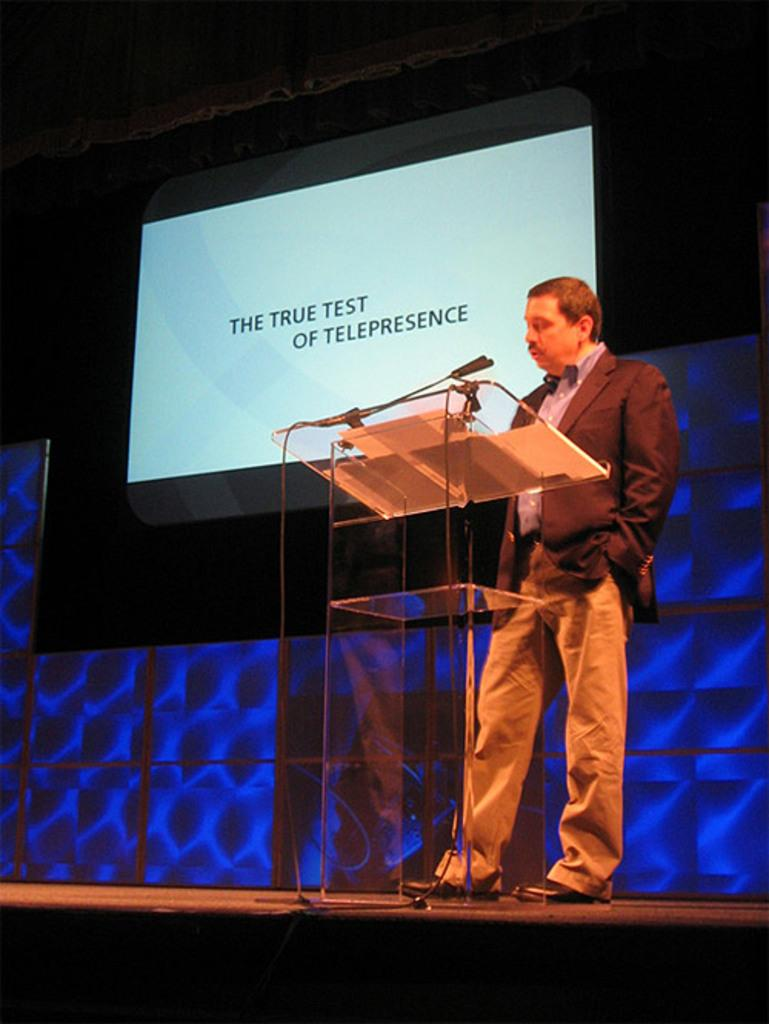What is the man doing in the image? The man is standing on the stage. What is the man standing near on the stage? The man is near a podium. What is the man holding or using for speaking? There is a microphone with a stand in the image. What can be seen in the background of the stage? There is a projector screen in the background. How many centimeters are the man's legs in the image? The image does not provide information about the length of the man's legs in centimeters. What type of cannon is present on the stage in the image? There is no cannon present on the stage in the image. 